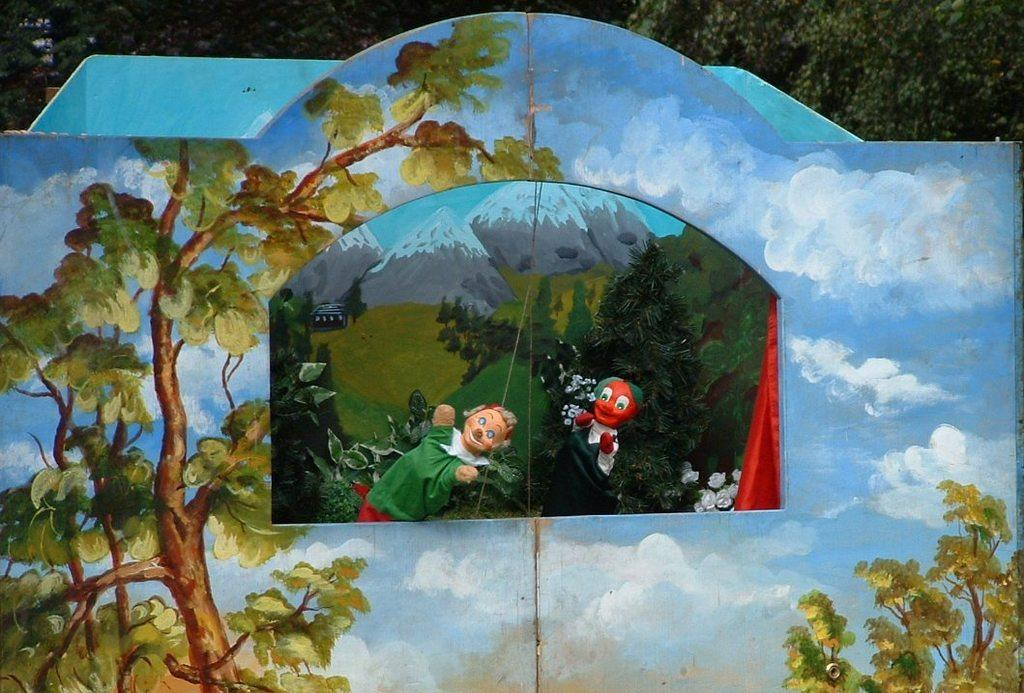What is the main subject of the image? The main subject of the image is a painting. What elements are depicted in the painting? The painting contains toys, mountains, and trees. What type of industry can be seen in the painting? There is no industry depicted in the painting; it contains toys, mountains, and trees. How does the ball interact with the toys in the painting? There is no ball present in the painting; it contains toys, mountains, and trees. 